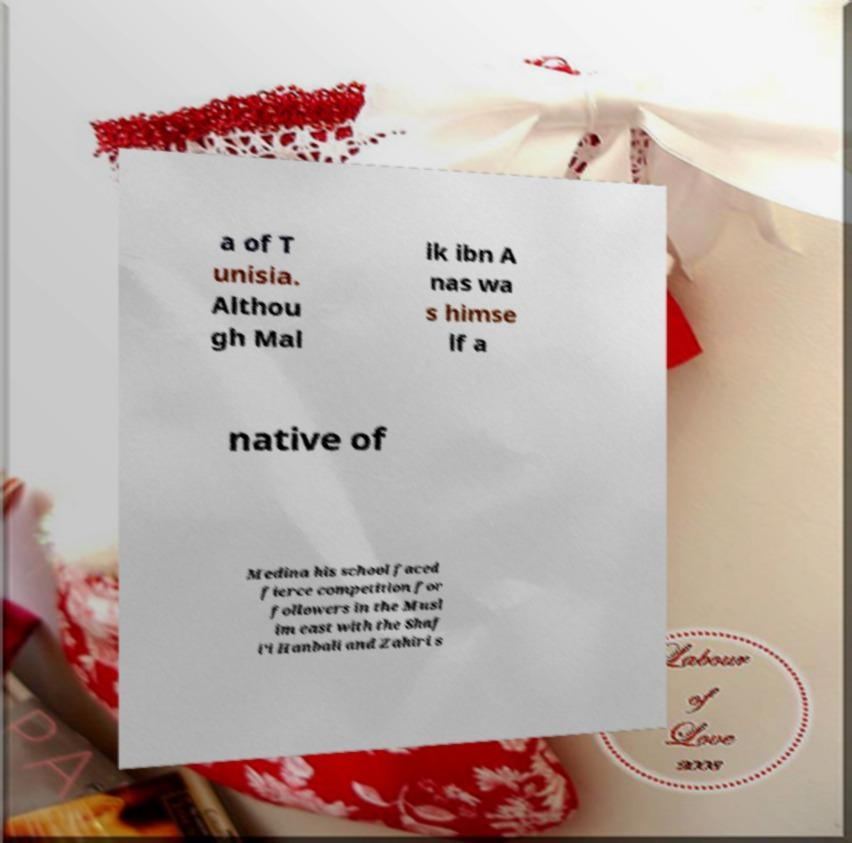I need the written content from this picture converted into text. Can you do that? a of T unisia. Althou gh Mal ik ibn A nas wa s himse lf a native of Medina his school faced fierce competition for followers in the Musl im east with the Shaf i'i Hanbali and Zahiri s 